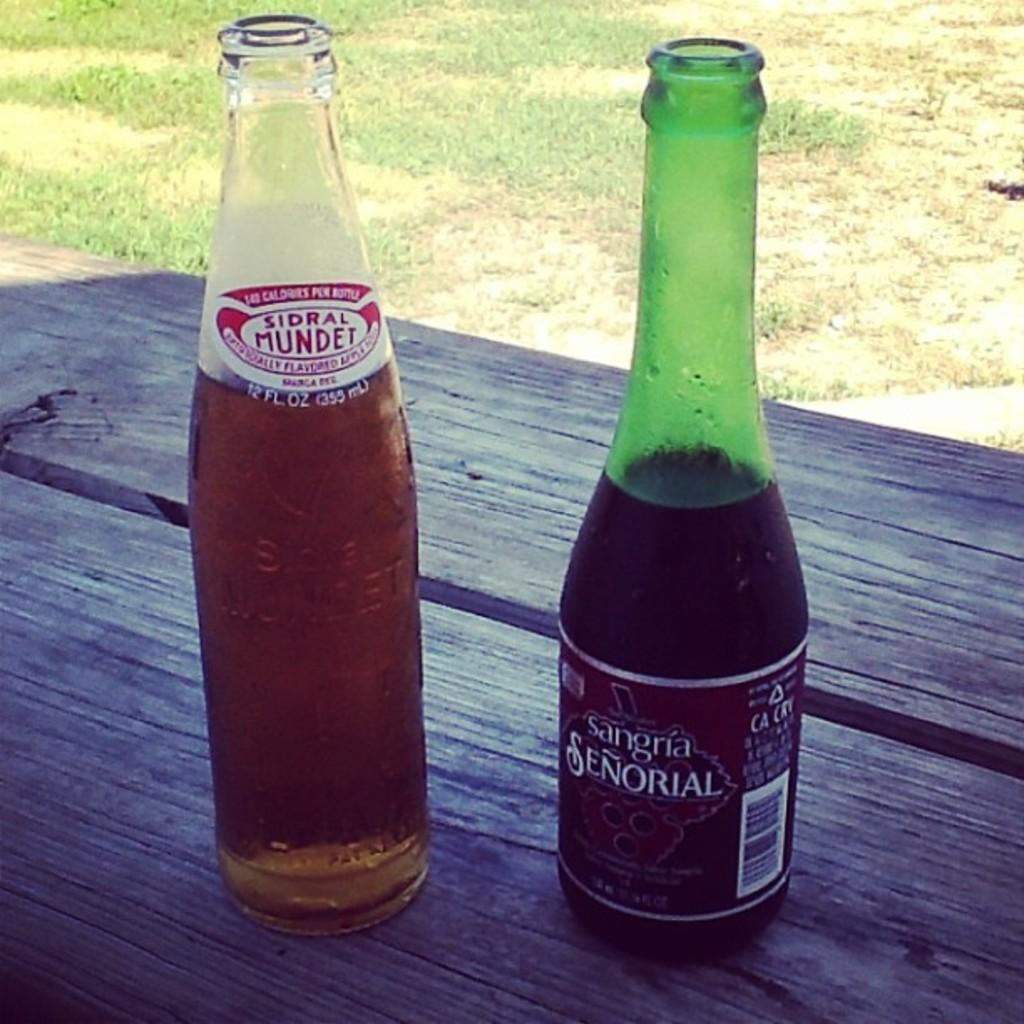<image>
Relay a brief, clear account of the picture shown. A bottle of Sidral Mundet and a bottle of Sangria Senorial on top of a table. 